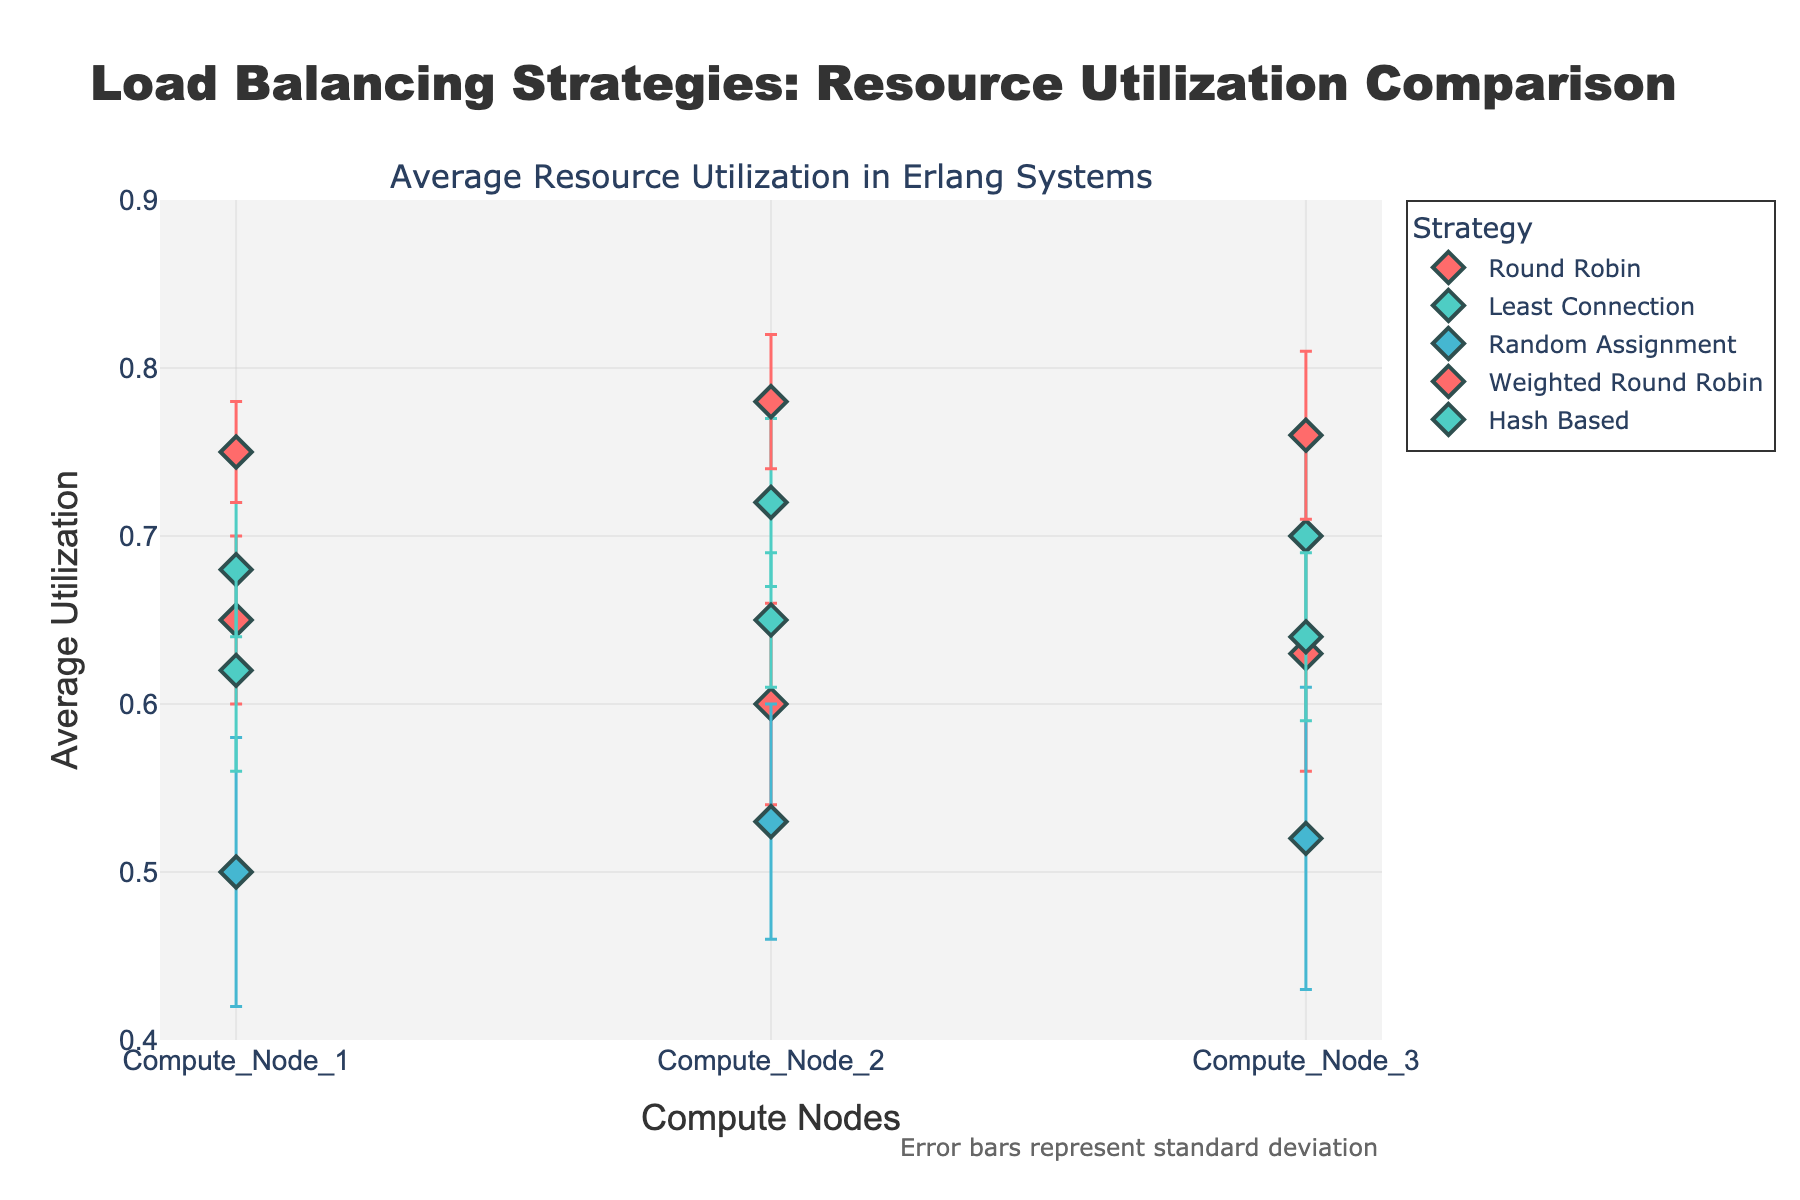What is the title of the figure? The title of the figure can be found in the top section of the plot. It summarizes the main content or purpose of the visualization.
Answer: "Load Balancing Strategies: Resource Utilization Comparison" How many different load balancing strategies are compared? Counting the number of unique load balancing strategies represented by different colored dots or distinct legends in the plot.
Answer: 5 Which load balancing strategy has the highest average utilization on Compute Node 2? Checking the y-values of the dots corresponding to Compute Node 2 and identifying the highest value and its corresponding strategy.
Answer: Weighted Round Robin What is the average utilization for Round Robin on Compute Node 3? Identifying the dot representing Round Robin on Compute Node 3 and noting down its y-value.
Answer: 0.63 Which compute node has the lowest average utilization under the Random Assignment strategy? Observing the data points for Random Assignment and comparing their y-values to find the lowest one.
Answer: Compute Node 1 Compare the average resource utilization between Compute Node 1 and Compute Node 3 for the Least Connection strategy. Checking the y-values for Compute Node 1 and Compute Node 3 under the Least Connection strategy and comparing them.
Answer: Compute Node 1: 0.68, Compute Node 3: 0.70. Compute Node 3 has higher utilization What is the maximum error (standard deviation) reported for the Hash Based strategy? Observing the length of the error bars (vertical lines) attached to the dots for the Hash Based strategy and identifying the longest one.
Answer: 0.06 Which load balancing strategy has the most consistent (least varying) average utilization across all compute nodes? Determining the strategy which has the smallest range or spread in its error bars across all represented compute nodes.
Answer: Weighted Round Robin On average, how do the utilization rates compare between the Round Robin and Hash Based strategies? Calculating the average utilization for all compute nodes under each strategy and comparing these two averages.
Answer: Round Robin: (0.65 + 0.60 + 0.63) / 3 = 0.63, Hash Based: (0.62 + 0.65 + 0.64) / 3 = 0.637. Hash Based is slightly higher Do any strategies show overlapping average utilization rates on Compute Node 2 within their error bars? Examining the error bars on Compute Node 2 for all strategies and determining if any error bars overlap, indicating similar utilization rates within their error ranges.
Answer: No strategies show overlapping average utilization rates within their error bars on Compute Node 2 